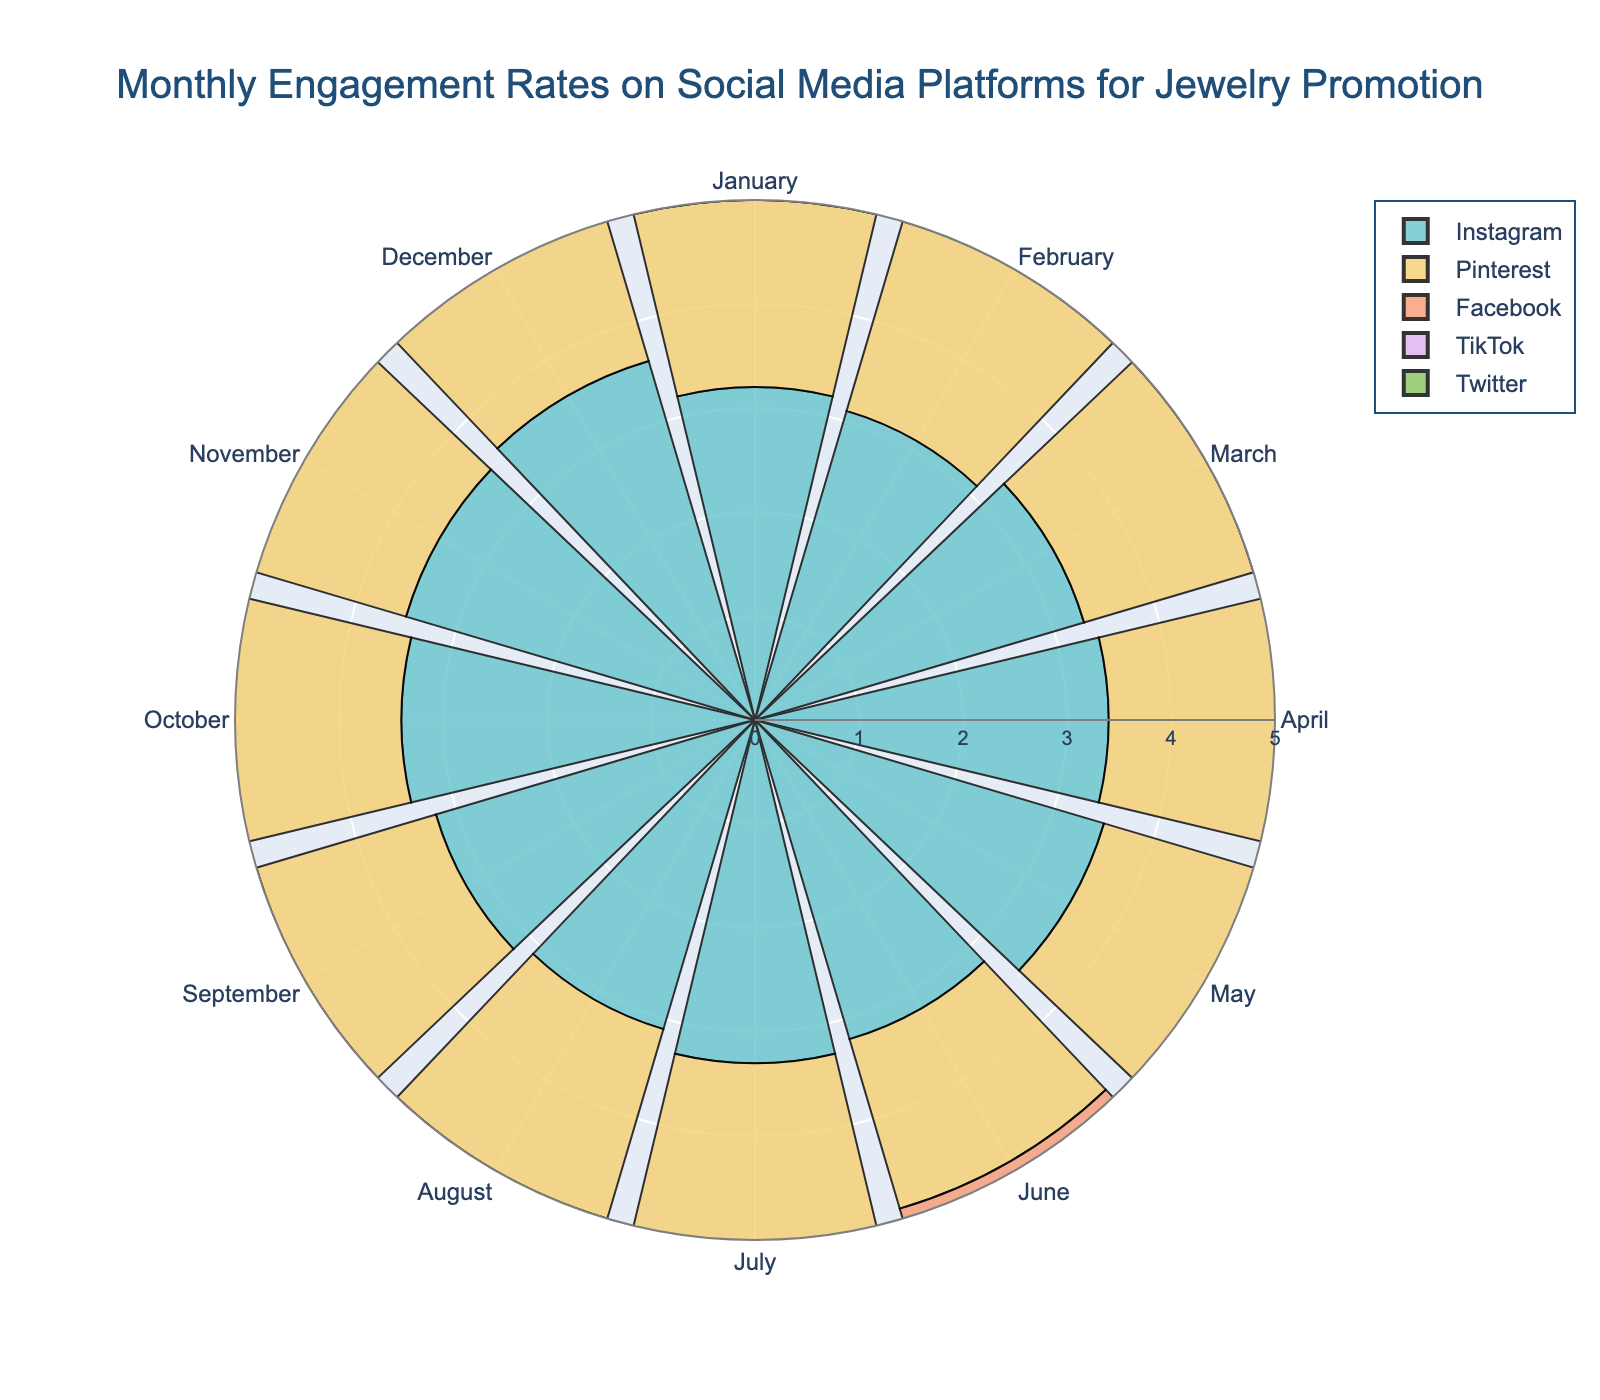Which platform shows the highest engagement rate for January? From the figure, locate the bar for January and compare the heights for each platform. TikTok has the highest engagement rate for January.
Answer: TikTok Which month has the highest engagement rate on Instagram? Find the bar for Instagram with the highest value. December has the highest engagement rate.
Answer: December What is the average engagement rate on Facebook for the first half of the year? Take the engagement rates for January to June on Facebook [(1.2 + 1.1 + 1.3 + 1.2 + 1.1 + 1.2) / 6] and calculate the average.
Answer: 1.18 Which platform has the most consistent engagement rate throughout the year? Look at the variance in bar lengths for each platform. Pinterest shows the most consistent engagement rates.
Answer: Pinterest Is there a month where TikTok's engagement rate is less than 4.5? Examine the bars for TikTok. None of the engagement rates for any month are below 4.5.
Answer: No What's the difference in engagement rate between Instagram and Twitter for May? Subtract Twitter’s engagement rate for May from Instagram's [(3.5 - 2.4)]. The difference is 1.1.
Answer: 1.1 Between Instagram and Pinterest, which platform has a greater engagement rate in March? Compare the March bars for Instagram and Pinterest. Instagram's engagement rate of 3.3 is higher than Pinterest's 1.7.
Answer: Instagram During which month is the difference in engagement rates between Facebook and Twitter the greatest? Examine the differences each month. Find that September has the highest difference [(2.4 - 1.4) = 1.0].
Answer: September How many months does TikTok have an engagement rate of exactly 4.6? Count the bars for TikTok that reach 4.6. There are four months with this rate (February, June, September, December).
Answer: 4 Which month has the lowest engagement rate on Pinterest? Identify the month with the shortest bar for Pinterest. March and October both have the lowest rate of 1.7.
Answer: March and October 